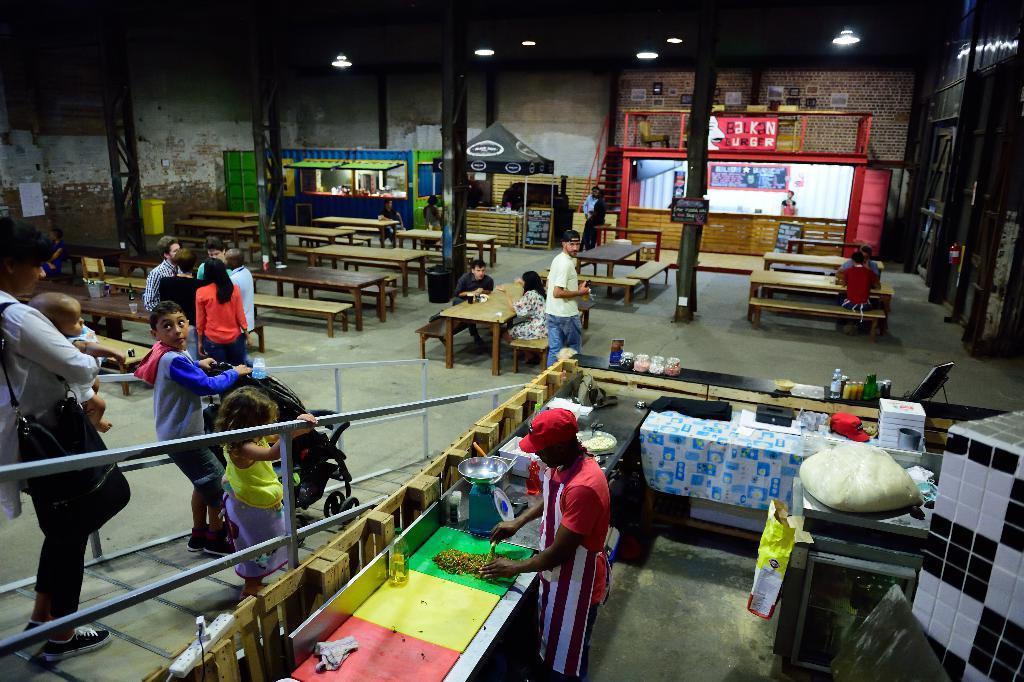How would you summarize this image in a sentence or two? This picture is of inside a hall. In the foreground we can see a man wearing red color t-shirt, standing and doing some work. On the left we can see group of persons standing and in the center there are two person sitting on the benches and there is a man seems to be walking and we can see there are many tables and benches in the room. In the background we can see the the tents, lights, metal rods and a wall. 